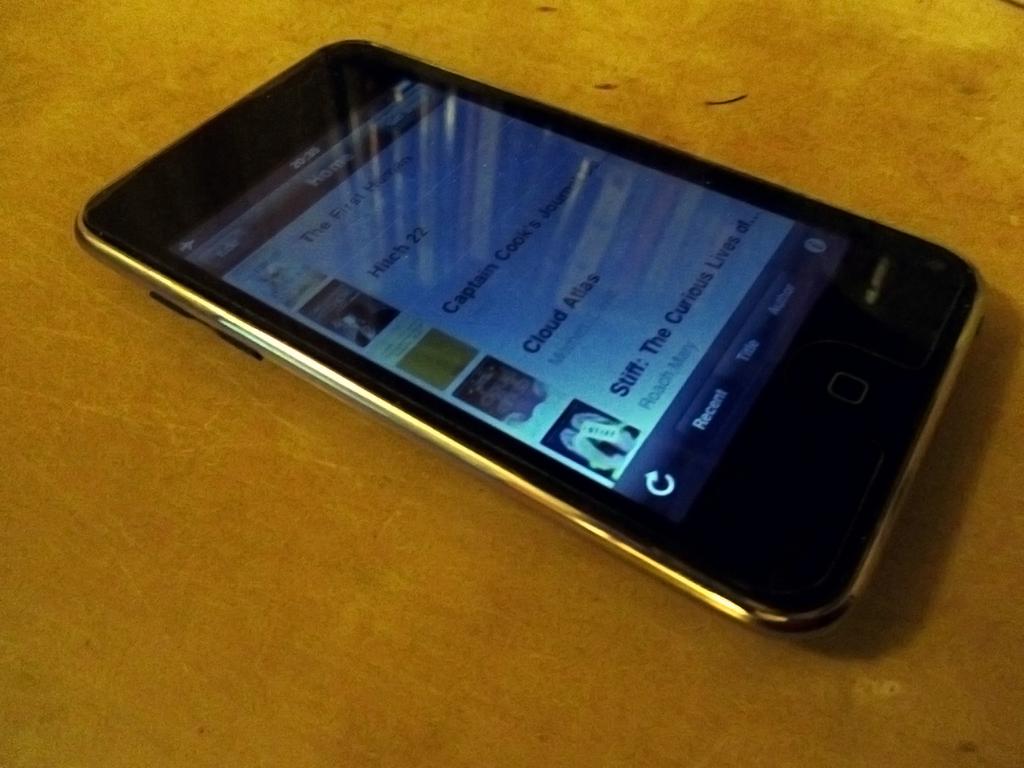What is the app on the bottom of the creen?
Give a very brief answer. Stiff. What is the first movie on the list?
Your response must be concise. Hitch 22. 